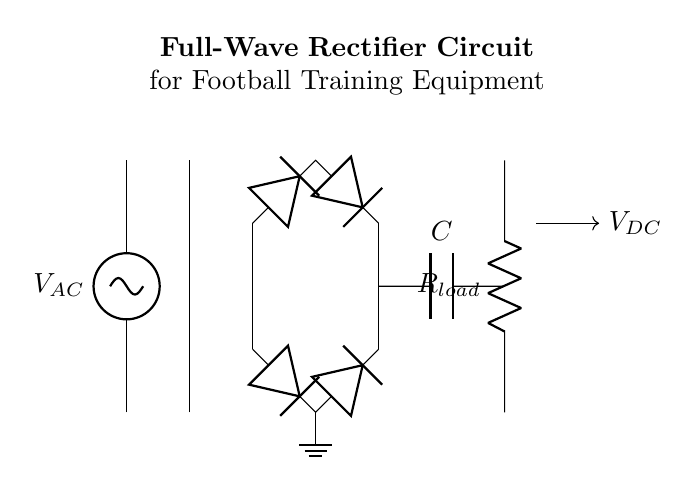What type of voltage does this circuit output? The circuit outputs direct current voltage, which is indicated by the label VDC connected to the load. This is achieved through the rectification process that converts the alternating current from the source into a steady, unidirectional flow of current.
Answer: direct current How many diodes are used in this circuit? The diagram shows a total of four diodes arranged in a bridge configuration. This allows the circuit to utilize both halves of the alternating current wave, providing a smoother output current to the load.
Answer: four What component smooths the output voltage? The capacitor, labeled C in the circuit, is responsible for smoothing out the output voltage. It charges during the peaks of the output and discharges during the troughs, thus reducing voltage fluctuations and providing a more stable direct current.
Answer: capacitor What is the purpose of the transformer in this circuit? The transformer steps down the incoming alternating voltage from the AC source to a lower voltage suitable for the rectifier and load. It ensures that the circuit operates within safe voltage limits for the subsequent components.
Answer: step down voltage Which component is responsible for converting AC to DC? The bridge rectifier, composed of four diodes, is responsible for converting the alternating current into direct current. It allows current to pass through regardless of the direction, effectively flipping the negative half-cycles to positive.
Answer: bridge rectifier 